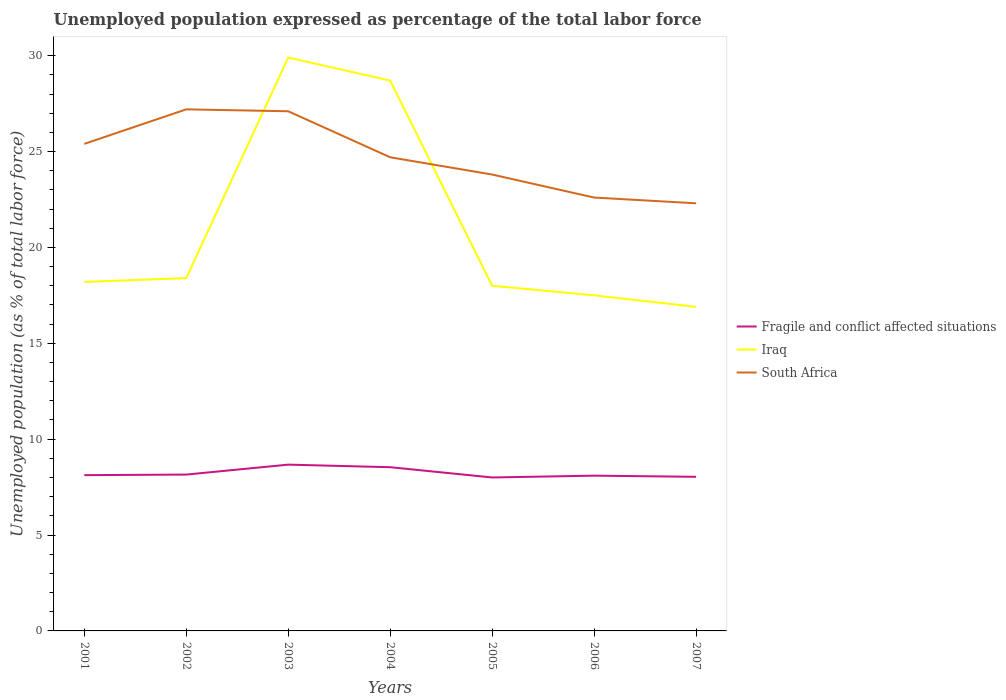How many different coloured lines are there?
Your response must be concise. 3. Does the line corresponding to South Africa intersect with the line corresponding to Fragile and conflict affected situations?
Make the answer very short. No. Is the number of lines equal to the number of legend labels?
Your answer should be compact. Yes. Across all years, what is the maximum unemployment in in South Africa?
Keep it short and to the point. 22.3. What is the total unemployment in in Fragile and conflict affected situations in the graph?
Give a very brief answer. 0.12. What is the difference between the highest and the second highest unemployment in in South Africa?
Your answer should be compact. 4.9. Is the unemployment in in Iraq strictly greater than the unemployment in in Fragile and conflict affected situations over the years?
Offer a terse response. No. How many years are there in the graph?
Provide a short and direct response. 7. What is the difference between two consecutive major ticks on the Y-axis?
Provide a succinct answer. 5. Are the values on the major ticks of Y-axis written in scientific E-notation?
Ensure brevity in your answer.  No. Does the graph contain grids?
Offer a very short reply. No. Where does the legend appear in the graph?
Offer a very short reply. Center right. How are the legend labels stacked?
Offer a very short reply. Vertical. What is the title of the graph?
Give a very brief answer. Unemployed population expressed as percentage of the total labor force. Does "Dominica" appear as one of the legend labels in the graph?
Offer a terse response. No. What is the label or title of the Y-axis?
Give a very brief answer. Unemployed population (as % of total labor force). What is the Unemployed population (as % of total labor force) in Fragile and conflict affected situations in 2001?
Provide a short and direct response. 8.12. What is the Unemployed population (as % of total labor force) in Iraq in 2001?
Provide a short and direct response. 18.2. What is the Unemployed population (as % of total labor force) in South Africa in 2001?
Offer a very short reply. 25.4. What is the Unemployed population (as % of total labor force) in Fragile and conflict affected situations in 2002?
Your answer should be very brief. 8.15. What is the Unemployed population (as % of total labor force) of Iraq in 2002?
Make the answer very short. 18.4. What is the Unemployed population (as % of total labor force) in South Africa in 2002?
Your answer should be very brief. 27.2. What is the Unemployed population (as % of total labor force) in Fragile and conflict affected situations in 2003?
Offer a very short reply. 8.67. What is the Unemployed population (as % of total labor force) in Iraq in 2003?
Offer a very short reply. 29.9. What is the Unemployed population (as % of total labor force) of South Africa in 2003?
Ensure brevity in your answer.  27.1. What is the Unemployed population (as % of total labor force) in Fragile and conflict affected situations in 2004?
Your answer should be compact. 8.54. What is the Unemployed population (as % of total labor force) in Iraq in 2004?
Give a very brief answer. 28.7. What is the Unemployed population (as % of total labor force) of South Africa in 2004?
Give a very brief answer. 24.7. What is the Unemployed population (as % of total labor force) in Fragile and conflict affected situations in 2005?
Your answer should be compact. 8. What is the Unemployed population (as % of total labor force) of South Africa in 2005?
Your answer should be very brief. 23.8. What is the Unemployed population (as % of total labor force) of Fragile and conflict affected situations in 2006?
Keep it short and to the point. 8.1. What is the Unemployed population (as % of total labor force) of South Africa in 2006?
Ensure brevity in your answer.  22.6. What is the Unemployed population (as % of total labor force) of Fragile and conflict affected situations in 2007?
Offer a very short reply. 8.04. What is the Unemployed population (as % of total labor force) of Iraq in 2007?
Ensure brevity in your answer.  16.9. What is the Unemployed population (as % of total labor force) of South Africa in 2007?
Offer a terse response. 22.3. Across all years, what is the maximum Unemployed population (as % of total labor force) in Fragile and conflict affected situations?
Offer a very short reply. 8.67. Across all years, what is the maximum Unemployed population (as % of total labor force) in Iraq?
Your answer should be very brief. 29.9. Across all years, what is the maximum Unemployed population (as % of total labor force) in South Africa?
Make the answer very short. 27.2. Across all years, what is the minimum Unemployed population (as % of total labor force) in Fragile and conflict affected situations?
Provide a succinct answer. 8. Across all years, what is the minimum Unemployed population (as % of total labor force) of Iraq?
Make the answer very short. 16.9. Across all years, what is the minimum Unemployed population (as % of total labor force) in South Africa?
Offer a very short reply. 22.3. What is the total Unemployed population (as % of total labor force) of Fragile and conflict affected situations in the graph?
Offer a terse response. 57.62. What is the total Unemployed population (as % of total labor force) in Iraq in the graph?
Your answer should be very brief. 147.6. What is the total Unemployed population (as % of total labor force) in South Africa in the graph?
Ensure brevity in your answer.  173.1. What is the difference between the Unemployed population (as % of total labor force) in Fragile and conflict affected situations in 2001 and that in 2002?
Your answer should be compact. -0.03. What is the difference between the Unemployed population (as % of total labor force) of South Africa in 2001 and that in 2002?
Your answer should be very brief. -1.8. What is the difference between the Unemployed population (as % of total labor force) of Fragile and conflict affected situations in 2001 and that in 2003?
Your answer should be compact. -0.55. What is the difference between the Unemployed population (as % of total labor force) of Iraq in 2001 and that in 2003?
Provide a succinct answer. -11.7. What is the difference between the Unemployed population (as % of total labor force) of Fragile and conflict affected situations in 2001 and that in 2004?
Give a very brief answer. -0.41. What is the difference between the Unemployed population (as % of total labor force) of South Africa in 2001 and that in 2004?
Provide a succinct answer. 0.7. What is the difference between the Unemployed population (as % of total labor force) in Fragile and conflict affected situations in 2001 and that in 2005?
Make the answer very short. 0.12. What is the difference between the Unemployed population (as % of total labor force) in Iraq in 2001 and that in 2005?
Offer a terse response. 0.2. What is the difference between the Unemployed population (as % of total labor force) in South Africa in 2001 and that in 2005?
Your answer should be very brief. 1.6. What is the difference between the Unemployed population (as % of total labor force) in Fragile and conflict affected situations in 2001 and that in 2006?
Your response must be concise. 0.03. What is the difference between the Unemployed population (as % of total labor force) in Fragile and conflict affected situations in 2001 and that in 2007?
Your answer should be compact. 0.09. What is the difference between the Unemployed population (as % of total labor force) of South Africa in 2001 and that in 2007?
Provide a short and direct response. 3.1. What is the difference between the Unemployed population (as % of total labor force) in Fragile and conflict affected situations in 2002 and that in 2003?
Offer a terse response. -0.52. What is the difference between the Unemployed population (as % of total labor force) in Fragile and conflict affected situations in 2002 and that in 2004?
Ensure brevity in your answer.  -0.38. What is the difference between the Unemployed population (as % of total labor force) of Iraq in 2002 and that in 2004?
Give a very brief answer. -10.3. What is the difference between the Unemployed population (as % of total labor force) in South Africa in 2002 and that in 2004?
Keep it short and to the point. 2.5. What is the difference between the Unemployed population (as % of total labor force) in Fragile and conflict affected situations in 2002 and that in 2005?
Your response must be concise. 0.15. What is the difference between the Unemployed population (as % of total labor force) of Iraq in 2002 and that in 2005?
Offer a very short reply. 0.4. What is the difference between the Unemployed population (as % of total labor force) in South Africa in 2002 and that in 2005?
Provide a short and direct response. 3.4. What is the difference between the Unemployed population (as % of total labor force) in Fragile and conflict affected situations in 2002 and that in 2006?
Offer a very short reply. 0.06. What is the difference between the Unemployed population (as % of total labor force) of Iraq in 2002 and that in 2006?
Offer a very short reply. 0.9. What is the difference between the Unemployed population (as % of total labor force) in South Africa in 2002 and that in 2006?
Keep it short and to the point. 4.6. What is the difference between the Unemployed population (as % of total labor force) of Fragile and conflict affected situations in 2002 and that in 2007?
Ensure brevity in your answer.  0.12. What is the difference between the Unemployed population (as % of total labor force) of Fragile and conflict affected situations in 2003 and that in 2004?
Provide a short and direct response. 0.13. What is the difference between the Unemployed population (as % of total labor force) in South Africa in 2003 and that in 2004?
Provide a short and direct response. 2.4. What is the difference between the Unemployed population (as % of total labor force) in Fragile and conflict affected situations in 2003 and that in 2005?
Ensure brevity in your answer.  0.67. What is the difference between the Unemployed population (as % of total labor force) of Fragile and conflict affected situations in 2003 and that in 2006?
Your answer should be compact. 0.58. What is the difference between the Unemployed population (as % of total labor force) of Iraq in 2003 and that in 2006?
Offer a terse response. 12.4. What is the difference between the Unemployed population (as % of total labor force) in South Africa in 2003 and that in 2006?
Your response must be concise. 4.5. What is the difference between the Unemployed population (as % of total labor force) in Fragile and conflict affected situations in 2003 and that in 2007?
Offer a very short reply. 0.64. What is the difference between the Unemployed population (as % of total labor force) of Iraq in 2003 and that in 2007?
Keep it short and to the point. 13. What is the difference between the Unemployed population (as % of total labor force) of South Africa in 2003 and that in 2007?
Your answer should be very brief. 4.8. What is the difference between the Unemployed population (as % of total labor force) in Fragile and conflict affected situations in 2004 and that in 2005?
Provide a short and direct response. 0.54. What is the difference between the Unemployed population (as % of total labor force) in South Africa in 2004 and that in 2005?
Your response must be concise. 0.9. What is the difference between the Unemployed population (as % of total labor force) of Fragile and conflict affected situations in 2004 and that in 2006?
Your answer should be very brief. 0.44. What is the difference between the Unemployed population (as % of total labor force) of Iraq in 2004 and that in 2006?
Your answer should be very brief. 11.2. What is the difference between the Unemployed population (as % of total labor force) in Fragile and conflict affected situations in 2004 and that in 2007?
Give a very brief answer. 0.5. What is the difference between the Unemployed population (as % of total labor force) in South Africa in 2004 and that in 2007?
Provide a short and direct response. 2.4. What is the difference between the Unemployed population (as % of total labor force) in Fragile and conflict affected situations in 2005 and that in 2006?
Offer a terse response. -0.09. What is the difference between the Unemployed population (as % of total labor force) in Iraq in 2005 and that in 2006?
Give a very brief answer. 0.5. What is the difference between the Unemployed population (as % of total labor force) in South Africa in 2005 and that in 2006?
Keep it short and to the point. 1.2. What is the difference between the Unemployed population (as % of total labor force) in Fragile and conflict affected situations in 2005 and that in 2007?
Your response must be concise. -0.03. What is the difference between the Unemployed population (as % of total labor force) of Iraq in 2005 and that in 2007?
Ensure brevity in your answer.  1.1. What is the difference between the Unemployed population (as % of total labor force) in Fragile and conflict affected situations in 2006 and that in 2007?
Make the answer very short. 0.06. What is the difference between the Unemployed population (as % of total labor force) in Fragile and conflict affected situations in 2001 and the Unemployed population (as % of total labor force) in Iraq in 2002?
Your answer should be compact. -10.28. What is the difference between the Unemployed population (as % of total labor force) of Fragile and conflict affected situations in 2001 and the Unemployed population (as % of total labor force) of South Africa in 2002?
Provide a short and direct response. -19.08. What is the difference between the Unemployed population (as % of total labor force) in Fragile and conflict affected situations in 2001 and the Unemployed population (as % of total labor force) in Iraq in 2003?
Offer a terse response. -21.78. What is the difference between the Unemployed population (as % of total labor force) of Fragile and conflict affected situations in 2001 and the Unemployed population (as % of total labor force) of South Africa in 2003?
Ensure brevity in your answer.  -18.98. What is the difference between the Unemployed population (as % of total labor force) of Iraq in 2001 and the Unemployed population (as % of total labor force) of South Africa in 2003?
Offer a terse response. -8.9. What is the difference between the Unemployed population (as % of total labor force) in Fragile and conflict affected situations in 2001 and the Unemployed population (as % of total labor force) in Iraq in 2004?
Ensure brevity in your answer.  -20.58. What is the difference between the Unemployed population (as % of total labor force) of Fragile and conflict affected situations in 2001 and the Unemployed population (as % of total labor force) of South Africa in 2004?
Offer a very short reply. -16.58. What is the difference between the Unemployed population (as % of total labor force) in Iraq in 2001 and the Unemployed population (as % of total labor force) in South Africa in 2004?
Offer a very short reply. -6.5. What is the difference between the Unemployed population (as % of total labor force) in Fragile and conflict affected situations in 2001 and the Unemployed population (as % of total labor force) in Iraq in 2005?
Offer a terse response. -9.88. What is the difference between the Unemployed population (as % of total labor force) of Fragile and conflict affected situations in 2001 and the Unemployed population (as % of total labor force) of South Africa in 2005?
Give a very brief answer. -15.68. What is the difference between the Unemployed population (as % of total labor force) of Fragile and conflict affected situations in 2001 and the Unemployed population (as % of total labor force) of Iraq in 2006?
Your answer should be very brief. -9.38. What is the difference between the Unemployed population (as % of total labor force) in Fragile and conflict affected situations in 2001 and the Unemployed population (as % of total labor force) in South Africa in 2006?
Ensure brevity in your answer.  -14.48. What is the difference between the Unemployed population (as % of total labor force) in Iraq in 2001 and the Unemployed population (as % of total labor force) in South Africa in 2006?
Ensure brevity in your answer.  -4.4. What is the difference between the Unemployed population (as % of total labor force) of Fragile and conflict affected situations in 2001 and the Unemployed population (as % of total labor force) of Iraq in 2007?
Offer a terse response. -8.78. What is the difference between the Unemployed population (as % of total labor force) in Fragile and conflict affected situations in 2001 and the Unemployed population (as % of total labor force) in South Africa in 2007?
Give a very brief answer. -14.18. What is the difference between the Unemployed population (as % of total labor force) in Fragile and conflict affected situations in 2002 and the Unemployed population (as % of total labor force) in Iraq in 2003?
Your response must be concise. -21.75. What is the difference between the Unemployed population (as % of total labor force) in Fragile and conflict affected situations in 2002 and the Unemployed population (as % of total labor force) in South Africa in 2003?
Offer a very short reply. -18.95. What is the difference between the Unemployed population (as % of total labor force) of Fragile and conflict affected situations in 2002 and the Unemployed population (as % of total labor force) of Iraq in 2004?
Give a very brief answer. -20.55. What is the difference between the Unemployed population (as % of total labor force) of Fragile and conflict affected situations in 2002 and the Unemployed population (as % of total labor force) of South Africa in 2004?
Keep it short and to the point. -16.55. What is the difference between the Unemployed population (as % of total labor force) of Fragile and conflict affected situations in 2002 and the Unemployed population (as % of total labor force) of Iraq in 2005?
Provide a short and direct response. -9.85. What is the difference between the Unemployed population (as % of total labor force) in Fragile and conflict affected situations in 2002 and the Unemployed population (as % of total labor force) in South Africa in 2005?
Your answer should be very brief. -15.65. What is the difference between the Unemployed population (as % of total labor force) of Fragile and conflict affected situations in 2002 and the Unemployed population (as % of total labor force) of Iraq in 2006?
Provide a succinct answer. -9.35. What is the difference between the Unemployed population (as % of total labor force) in Fragile and conflict affected situations in 2002 and the Unemployed population (as % of total labor force) in South Africa in 2006?
Your response must be concise. -14.45. What is the difference between the Unemployed population (as % of total labor force) in Iraq in 2002 and the Unemployed population (as % of total labor force) in South Africa in 2006?
Make the answer very short. -4.2. What is the difference between the Unemployed population (as % of total labor force) in Fragile and conflict affected situations in 2002 and the Unemployed population (as % of total labor force) in Iraq in 2007?
Provide a succinct answer. -8.75. What is the difference between the Unemployed population (as % of total labor force) of Fragile and conflict affected situations in 2002 and the Unemployed population (as % of total labor force) of South Africa in 2007?
Ensure brevity in your answer.  -14.15. What is the difference between the Unemployed population (as % of total labor force) of Iraq in 2002 and the Unemployed population (as % of total labor force) of South Africa in 2007?
Provide a succinct answer. -3.9. What is the difference between the Unemployed population (as % of total labor force) of Fragile and conflict affected situations in 2003 and the Unemployed population (as % of total labor force) of Iraq in 2004?
Ensure brevity in your answer.  -20.03. What is the difference between the Unemployed population (as % of total labor force) of Fragile and conflict affected situations in 2003 and the Unemployed population (as % of total labor force) of South Africa in 2004?
Keep it short and to the point. -16.03. What is the difference between the Unemployed population (as % of total labor force) in Iraq in 2003 and the Unemployed population (as % of total labor force) in South Africa in 2004?
Offer a terse response. 5.2. What is the difference between the Unemployed population (as % of total labor force) of Fragile and conflict affected situations in 2003 and the Unemployed population (as % of total labor force) of Iraq in 2005?
Your answer should be compact. -9.33. What is the difference between the Unemployed population (as % of total labor force) of Fragile and conflict affected situations in 2003 and the Unemployed population (as % of total labor force) of South Africa in 2005?
Make the answer very short. -15.13. What is the difference between the Unemployed population (as % of total labor force) of Iraq in 2003 and the Unemployed population (as % of total labor force) of South Africa in 2005?
Your answer should be very brief. 6.1. What is the difference between the Unemployed population (as % of total labor force) of Fragile and conflict affected situations in 2003 and the Unemployed population (as % of total labor force) of Iraq in 2006?
Your response must be concise. -8.83. What is the difference between the Unemployed population (as % of total labor force) in Fragile and conflict affected situations in 2003 and the Unemployed population (as % of total labor force) in South Africa in 2006?
Provide a short and direct response. -13.93. What is the difference between the Unemployed population (as % of total labor force) of Fragile and conflict affected situations in 2003 and the Unemployed population (as % of total labor force) of Iraq in 2007?
Ensure brevity in your answer.  -8.23. What is the difference between the Unemployed population (as % of total labor force) of Fragile and conflict affected situations in 2003 and the Unemployed population (as % of total labor force) of South Africa in 2007?
Offer a terse response. -13.63. What is the difference between the Unemployed population (as % of total labor force) in Iraq in 2003 and the Unemployed population (as % of total labor force) in South Africa in 2007?
Your answer should be compact. 7.6. What is the difference between the Unemployed population (as % of total labor force) in Fragile and conflict affected situations in 2004 and the Unemployed population (as % of total labor force) in Iraq in 2005?
Your response must be concise. -9.46. What is the difference between the Unemployed population (as % of total labor force) of Fragile and conflict affected situations in 2004 and the Unemployed population (as % of total labor force) of South Africa in 2005?
Offer a terse response. -15.26. What is the difference between the Unemployed population (as % of total labor force) of Iraq in 2004 and the Unemployed population (as % of total labor force) of South Africa in 2005?
Offer a terse response. 4.9. What is the difference between the Unemployed population (as % of total labor force) of Fragile and conflict affected situations in 2004 and the Unemployed population (as % of total labor force) of Iraq in 2006?
Your response must be concise. -8.96. What is the difference between the Unemployed population (as % of total labor force) in Fragile and conflict affected situations in 2004 and the Unemployed population (as % of total labor force) in South Africa in 2006?
Ensure brevity in your answer.  -14.06. What is the difference between the Unemployed population (as % of total labor force) in Fragile and conflict affected situations in 2004 and the Unemployed population (as % of total labor force) in Iraq in 2007?
Your answer should be compact. -8.36. What is the difference between the Unemployed population (as % of total labor force) in Fragile and conflict affected situations in 2004 and the Unemployed population (as % of total labor force) in South Africa in 2007?
Your answer should be compact. -13.76. What is the difference between the Unemployed population (as % of total labor force) in Fragile and conflict affected situations in 2005 and the Unemployed population (as % of total labor force) in Iraq in 2006?
Provide a succinct answer. -9.5. What is the difference between the Unemployed population (as % of total labor force) in Fragile and conflict affected situations in 2005 and the Unemployed population (as % of total labor force) in South Africa in 2006?
Provide a succinct answer. -14.6. What is the difference between the Unemployed population (as % of total labor force) of Fragile and conflict affected situations in 2005 and the Unemployed population (as % of total labor force) of Iraq in 2007?
Provide a succinct answer. -8.9. What is the difference between the Unemployed population (as % of total labor force) of Fragile and conflict affected situations in 2005 and the Unemployed population (as % of total labor force) of South Africa in 2007?
Your answer should be very brief. -14.3. What is the difference between the Unemployed population (as % of total labor force) in Iraq in 2005 and the Unemployed population (as % of total labor force) in South Africa in 2007?
Keep it short and to the point. -4.3. What is the difference between the Unemployed population (as % of total labor force) of Fragile and conflict affected situations in 2006 and the Unemployed population (as % of total labor force) of Iraq in 2007?
Give a very brief answer. -8.8. What is the difference between the Unemployed population (as % of total labor force) in Fragile and conflict affected situations in 2006 and the Unemployed population (as % of total labor force) in South Africa in 2007?
Make the answer very short. -14.2. What is the difference between the Unemployed population (as % of total labor force) of Iraq in 2006 and the Unemployed population (as % of total labor force) of South Africa in 2007?
Keep it short and to the point. -4.8. What is the average Unemployed population (as % of total labor force) of Fragile and conflict affected situations per year?
Keep it short and to the point. 8.23. What is the average Unemployed population (as % of total labor force) of Iraq per year?
Provide a succinct answer. 21.09. What is the average Unemployed population (as % of total labor force) in South Africa per year?
Offer a terse response. 24.73. In the year 2001, what is the difference between the Unemployed population (as % of total labor force) of Fragile and conflict affected situations and Unemployed population (as % of total labor force) of Iraq?
Provide a short and direct response. -10.08. In the year 2001, what is the difference between the Unemployed population (as % of total labor force) of Fragile and conflict affected situations and Unemployed population (as % of total labor force) of South Africa?
Provide a short and direct response. -17.28. In the year 2002, what is the difference between the Unemployed population (as % of total labor force) in Fragile and conflict affected situations and Unemployed population (as % of total labor force) in Iraq?
Provide a short and direct response. -10.25. In the year 2002, what is the difference between the Unemployed population (as % of total labor force) of Fragile and conflict affected situations and Unemployed population (as % of total labor force) of South Africa?
Offer a terse response. -19.05. In the year 2002, what is the difference between the Unemployed population (as % of total labor force) in Iraq and Unemployed population (as % of total labor force) in South Africa?
Your answer should be very brief. -8.8. In the year 2003, what is the difference between the Unemployed population (as % of total labor force) of Fragile and conflict affected situations and Unemployed population (as % of total labor force) of Iraq?
Your answer should be very brief. -21.23. In the year 2003, what is the difference between the Unemployed population (as % of total labor force) of Fragile and conflict affected situations and Unemployed population (as % of total labor force) of South Africa?
Offer a terse response. -18.43. In the year 2003, what is the difference between the Unemployed population (as % of total labor force) of Iraq and Unemployed population (as % of total labor force) of South Africa?
Give a very brief answer. 2.8. In the year 2004, what is the difference between the Unemployed population (as % of total labor force) of Fragile and conflict affected situations and Unemployed population (as % of total labor force) of Iraq?
Provide a succinct answer. -20.16. In the year 2004, what is the difference between the Unemployed population (as % of total labor force) of Fragile and conflict affected situations and Unemployed population (as % of total labor force) of South Africa?
Your answer should be compact. -16.16. In the year 2004, what is the difference between the Unemployed population (as % of total labor force) in Iraq and Unemployed population (as % of total labor force) in South Africa?
Provide a short and direct response. 4. In the year 2005, what is the difference between the Unemployed population (as % of total labor force) in Fragile and conflict affected situations and Unemployed population (as % of total labor force) in Iraq?
Offer a terse response. -10. In the year 2005, what is the difference between the Unemployed population (as % of total labor force) of Fragile and conflict affected situations and Unemployed population (as % of total labor force) of South Africa?
Ensure brevity in your answer.  -15.8. In the year 2006, what is the difference between the Unemployed population (as % of total labor force) in Fragile and conflict affected situations and Unemployed population (as % of total labor force) in Iraq?
Ensure brevity in your answer.  -9.4. In the year 2006, what is the difference between the Unemployed population (as % of total labor force) in Fragile and conflict affected situations and Unemployed population (as % of total labor force) in South Africa?
Offer a very short reply. -14.5. In the year 2007, what is the difference between the Unemployed population (as % of total labor force) of Fragile and conflict affected situations and Unemployed population (as % of total labor force) of Iraq?
Provide a short and direct response. -8.86. In the year 2007, what is the difference between the Unemployed population (as % of total labor force) in Fragile and conflict affected situations and Unemployed population (as % of total labor force) in South Africa?
Keep it short and to the point. -14.26. In the year 2007, what is the difference between the Unemployed population (as % of total labor force) in Iraq and Unemployed population (as % of total labor force) in South Africa?
Make the answer very short. -5.4. What is the ratio of the Unemployed population (as % of total labor force) in Iraq in 2001 to that in 2002?
Provide a succinct answer. 0.99. What is the ratio of the Unemployed population (as % of total labor force) in South Africa in 2001 to that in 2002?
Offer a terse response. 0.93. What is the ratio of the Unemployed population (as % of total labor force) of Fragile and conflict affected situations in 2001 to that in 2003?
Provide a succinct answer. 0.94. What is the ratio of the Unemployed population (as % of total labor force) of Iraq in 2001 to that in 2003?
Offer a terse response. 0.61. What is the ratio of the Unemployed population (as % of total labor force) in South Africa in 2001 to that in 2003?
Give a very brief answer. 0.94. What is the ratio of the Unemployed population (as % of total labor force) in Fragile and conflict affected situations in 2001 to that in 2004?
Your answer should be very brief. 0.95. What is the ratio of the Unemployed population (as % of total labor force) in Iraq in 2001 to that in 2004?
Your answer should be very brief. 0.63. What is the ratio of the Unemployed population (as % of total labor force) of South Africa in 2001 to that in 2004?
Keep it short and to the point. 1.03. What is the ratio of the Unemployed population (as % of total labor force) in Fragile and conflict affected situations in 2001 to that in 2005?
Offer a terse response. 1.02. What is the ratio of the Unemployed population (as % of total labor force) of Iraq in 2001 to that in 2005?
Offer a terse response. 1.01. What is the ratio of the Unemployed population (as % of total labor force) of South Africa in 2001 to that in 2005?
Offer a very short reply. 1.07. What is the ratio of the Unemployed population (as % of total labor force) of South Africa in 2001 to that in 2006?
Keep it short and to the point. 1.12. What is the ratio of the Unemployed population (as % of total labor force) in Fragile and conflict affected situations in 2001 to that in 2007?
Give a very brief answer. 1.01. What is the ratio of the Unemployed population (as % of total labor force) of Iraq in 2001 to that in 2007?
Offer a very short reply. 1.08. What is the ratio of the Unemployed population (as % of total labor force) of South Africa in 2001 to that in 2007?
Offer a very short reply. 1.14. What is the ratio of the Unemployed population (as % of total labor force) of Fragile and conflict affected situations in 2002 to that in 2003?
Your answer should be compact. 0.94. What is the ratio of the Unemployed population (as % of total labor force) of Iraq in 2002 to that in 2003?
Make the answer very short. 0.62. What is the ratio of the Unemployed population (as % of total labor force) of Fragile and conflict affected situations in 2002 to that in 2004?
Your answer should be compact. 0.95. What is the ratio of the Unemployed population (as % of total labor force) of Iraq in 2002 to that in 2004?
Keep it short and to the point. 0.64. What is the ratio of the Unemployed population (as % of total labor force) in South Africa in 2002 to that in 2004?
Provide a short and direct response. 1.1. What is the ratio of the Unemployed population (as % of total labor force) of Fragile and conflict affected situations in 2002 to that in 2005?
Give a very brief answer. 1.02. What is the ratio of the Unemployed population (as % of total labor force) of Iraq in 2002 to that in 2005?
Keep it short and to the point. 1.02. What is the ratio of the Unemployed population (as % of total labor force) of South Africa in 2002 to that in 2005?
Your answer should be very brief. 1.14. What is the ratio of the Unemployed population (as % of total labor force) in Fragile and conflict affected situations in 2002 to that in 2006?
Make the answer very short. 1.01. What is the ratio of the Unemployed population (as % of total labor force) in Iraq in 2002 to that in 2006?
Give a very brief answer. 1.05. What is the ratio of the Unemployed population (as % of total labor force) in South Africa in 2002 to that in 2006?
Keep it short and to the point. 1.2. What is the ratio of the Unemployed population (as % of total labor force) in Fragile and conflict affected situations in 2002 to that in 2007?
Your response must be concise. 1.01. What is the ratio of the Unemployed population (as % of total labor force) in Iraq in 2002 to that in 2007?
Your answer should be compact. 1.09. What is the ratio of the Unemployed population (as % of total labor force) of South Africa in 2002 to that in 2007?
Offer a terse response. 1.22. What is the ratio of the Unemployed population (as % of total labor force) of Fragile and conflict affected situations in 2003 to that in 2004?
Offer a very short reply. 1.02. What is the ratio of the Unemployed population (as % of total labor force) of Iraq in 2003 to that in 2004?
Your answer should be compact. 1.04. What is the ratio of the Unemployed population (as % of total labor force) of South Africa in 2003 to that in 2004?
Your response must be concise. 1.1. What is the ratio of the Unemployed population (as % of total labor force) of Fragile and conflict affected situations in 2003 to that in 2005?
Offer a very short reply. 1.08. What is the ratio of the Unemployed population (as % of total labor force) in Iraq in 2003 to that in 2005?
Keep it short and to the point. 1.66. What is the ratio of the Unemployed population (as % of total labor force) of South Africa in 2003 to that in 2005?
Your answer should be very brief. 1.14. What is the ratio of the Unemployed population (as % of total labor force) of Fragile and conflict affected situations in 2003 to that in 2006?
Provide a succinct answer. 1.07. What is the ratio of the Unemployed population (as % of total labor force) in Iraq in 2003 to that in 2006?
Keep it short and to the point. 1.71. What is the ratio of the Unemployed population (as % of total labor force) of South Africa in 2003 to that in 2006?
Offer a very short reply. 1.2. What is the ratio of the Unemployed population (as % of total labor force) of Fragile and conflict affected situations in 2003 to that in 2007?
Your answer should be very brief. 1.08. What is the ratio of the Unemployed population (as % of total labor force) in Iraq in 2003 to that in 2007?
Your answer should be compact. 1.77. What is the ratio of the Unemployed population (as % of total labor force) of South Africa in 2003 to that in 2007?
Offer a terse response. 1.22. What is the ratio of the Unemployed population (as % of total labor force) of Fragile and conflict affected situations in 2004 to that in 2005?
Offer a terse response. 1.07. What is the ratio of the Unemployed population (as % of total labor force) in Iraq in 2004 to that in 2005?
Your answer should be compact. 1.59. What is the ratio of the Unemployed population (as % of total labor force) of South Africa in 2004 to that in 2005?
Your answer should be very brief. 1.04. What is the ratio of the Unemployed population (as % of total labor force) in Fragile and conflict affected situations in 2004 to that in 2006?
Keep it short and to the point. 1.05. What is the ratio of the Unemployed population (as % of total labor force) in Iraq in 2004 to that in 2006?
Your response must be concise. 1.64. What is the ratio of the Unemployed population (as % of total labor force) of South Africa in 2004 to that in 2006?
Offer a terse response. 1.09. What is the ratio of the Unemployed population (as % of total labor force) in Fragile and conflict affected situations in 2004 to that in 2007?
Ensure brevity in your answer.  1.06. What is the ratio of the Unemployed population (as % of total labor force) of Iraq in 2004 to that in 2007?
Your answer should be very brief. 1.7. What is the ratio of the Unemployed population (as % of total labor force) of South Africa in 2004 to that in 2007?
Provide a succinct answer. 1.11. What is the ratio of the Unemployed population (as % of total labor force) of Fragile and conflict affected situations in 2005 to that in 2006?
Provide a short and direct response. 0.99. What is the ratio of the Unemployed population (as % of total labor force) of Iraq in 2005 to that in 2006?
Provide a succinct answer. 1.03. What is the ratio of the Unemployed population (as % of total labor force) of South Africa in 2005 to that in 2006?
Your answer should be compact. 1.05. What is the ratio of the Unemployed population (as % of total labor force) of Iraq in 2005 to that in 2007?
Provide a succinct answer. 1.07. What is the ratio of the Unemployed population (as % of total labor force) in South Africa in 2005 to that in 2007?
Your answer should be compact. 1.07. What is the ratio of the Unemployed population (as % of total labor force) of Fragile and conflict affected situations in 2006 to that in 2007?
Provide a short and direct response. 1.01. What is the ratio of the Unemployed population (as % of total labor force) in Iraq in 2006 to that in 2007?
Give a very brief answer. 1.04. What is the ratio of the Unemployed population (as % of total labor force) of South Africa in 2006 to that in 2007?
Provide a short and direct response. 1.01. What is the difference between the highest and the second highest Unemployed population (as % of total labor force) of Fragile and conflict affected situations?
Your response must be concise. 0.13. What is the difference between the highest and the second highest Unemployed population (as % of total labor force) of South Africa?
Your response must be concise. 0.1. What is the difference between the highest and the lowest Unemployed population (as % of total labor force) of Fragile and conflict affected situations?
Make the answer very short. 0.67. What is the difference between the highest and the lowest Unemployed population (as % of total labor force) of South Africa?
Your response must be concise. 4.9. 